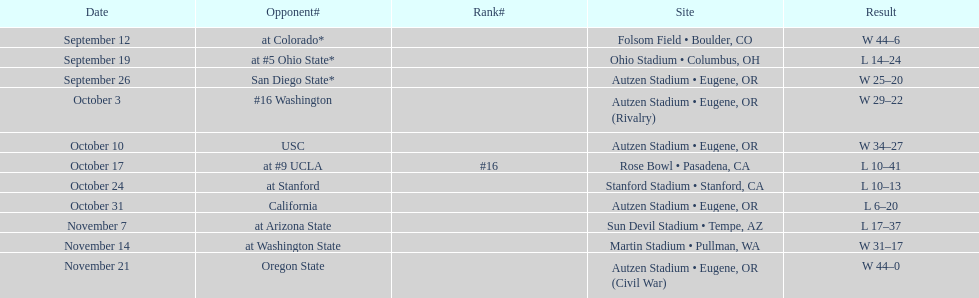Was the team's number of games won greater than the games lost? Win. 